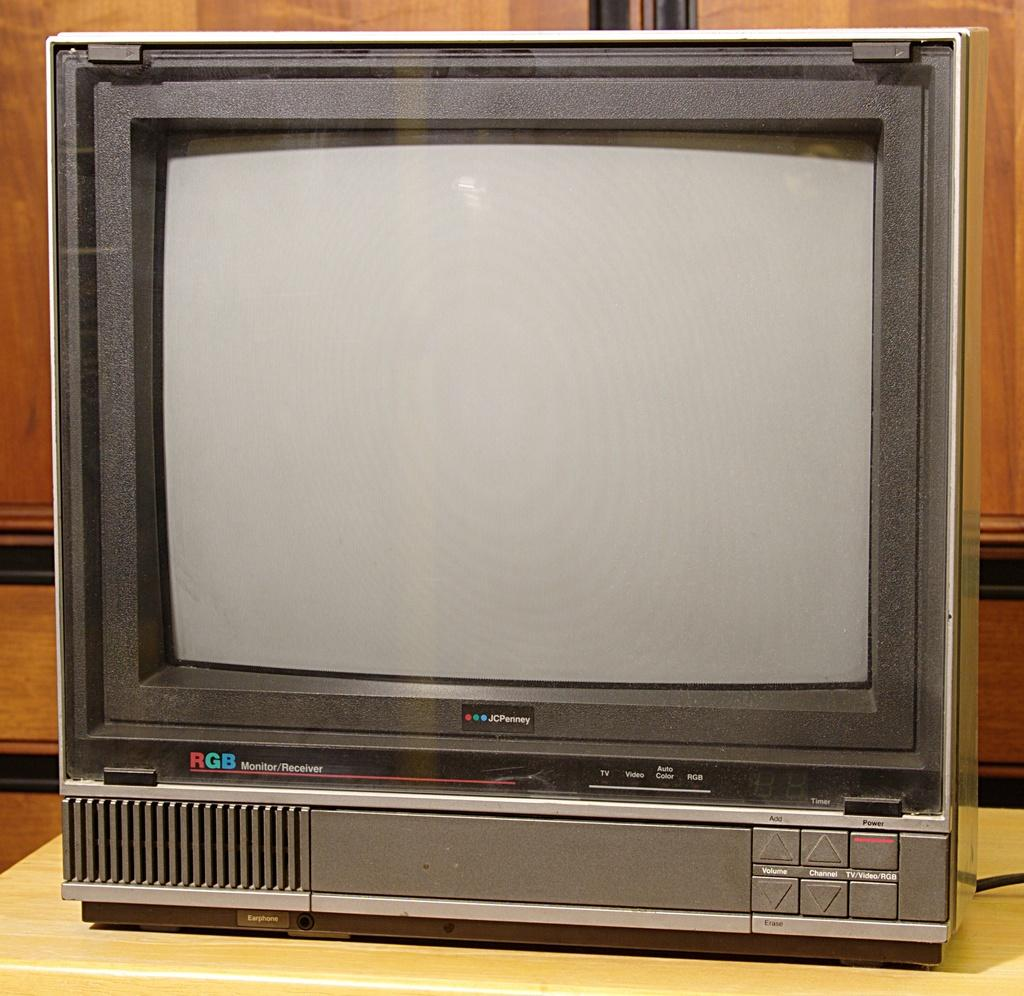<image>
Give a short and clear explanation of the subsequent image. Television screen which says JCPenny near the bottom. 